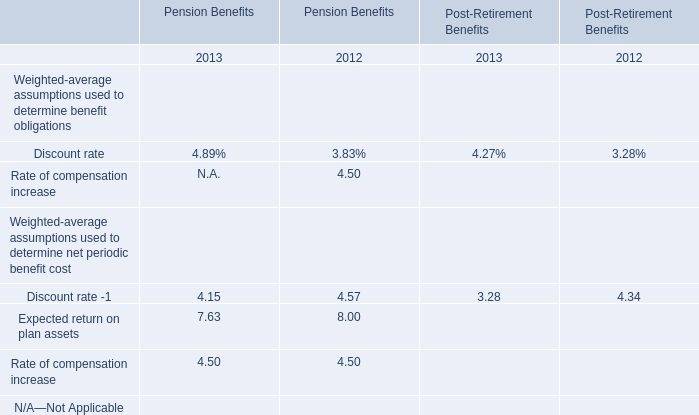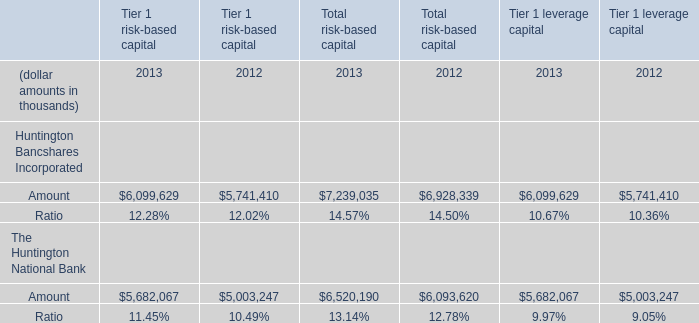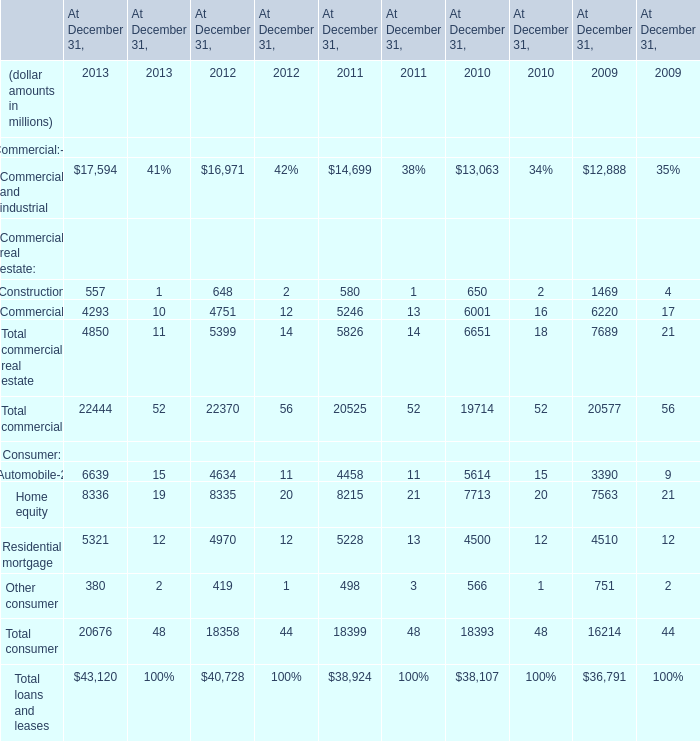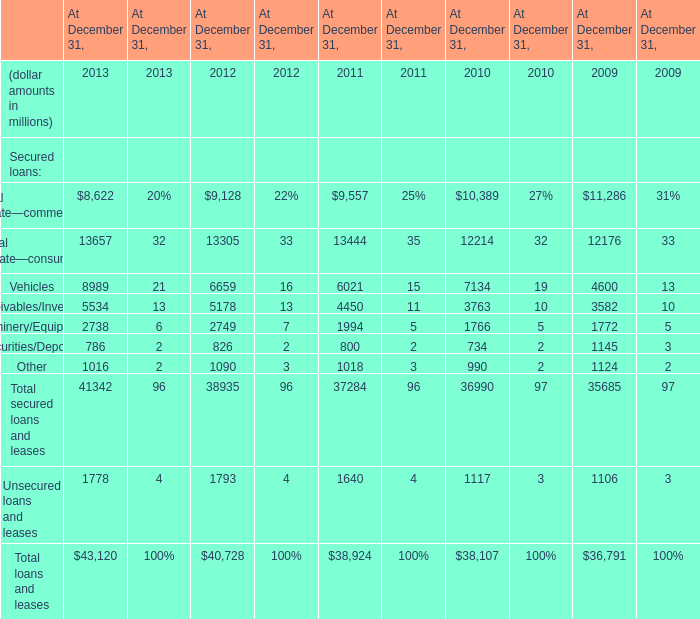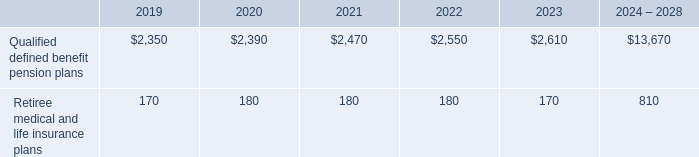What's the increasing rate of the amount of Total secured loans and leases on December 31 in 2011? 
Computations: ((37284 - 36990) / 36990)
Answer: 0.00795. 